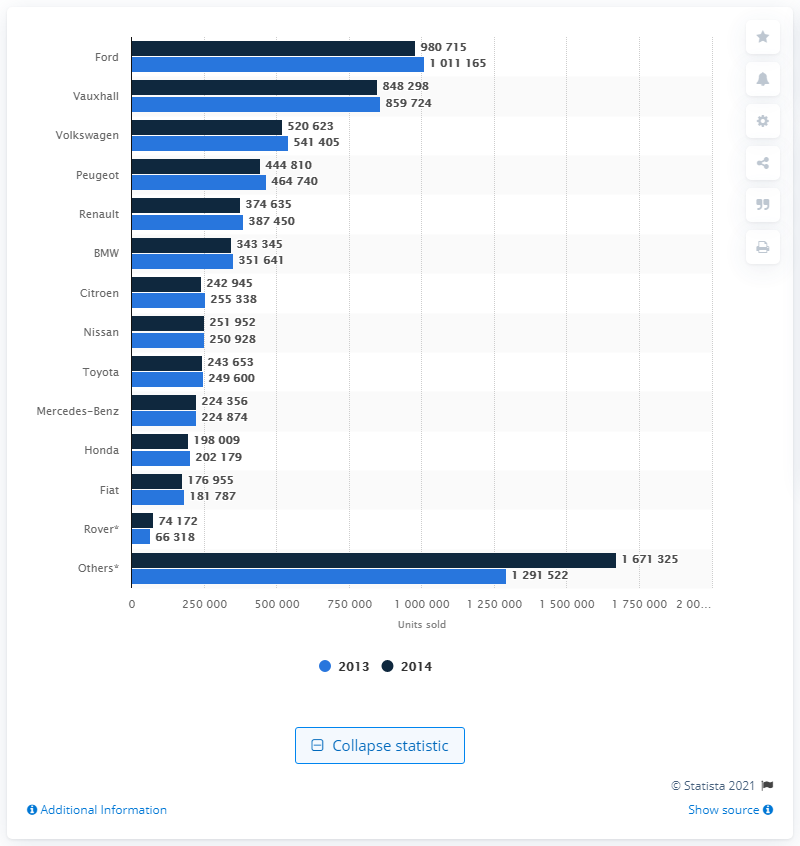Specify some key components in this picture. In 2013, Ford's used car sales declined by a significant amount. Specifically, the decline was 859,724 units. In 2013 and 2014, a total of 859,724 used Vauxhall cars were sold in the UK. 